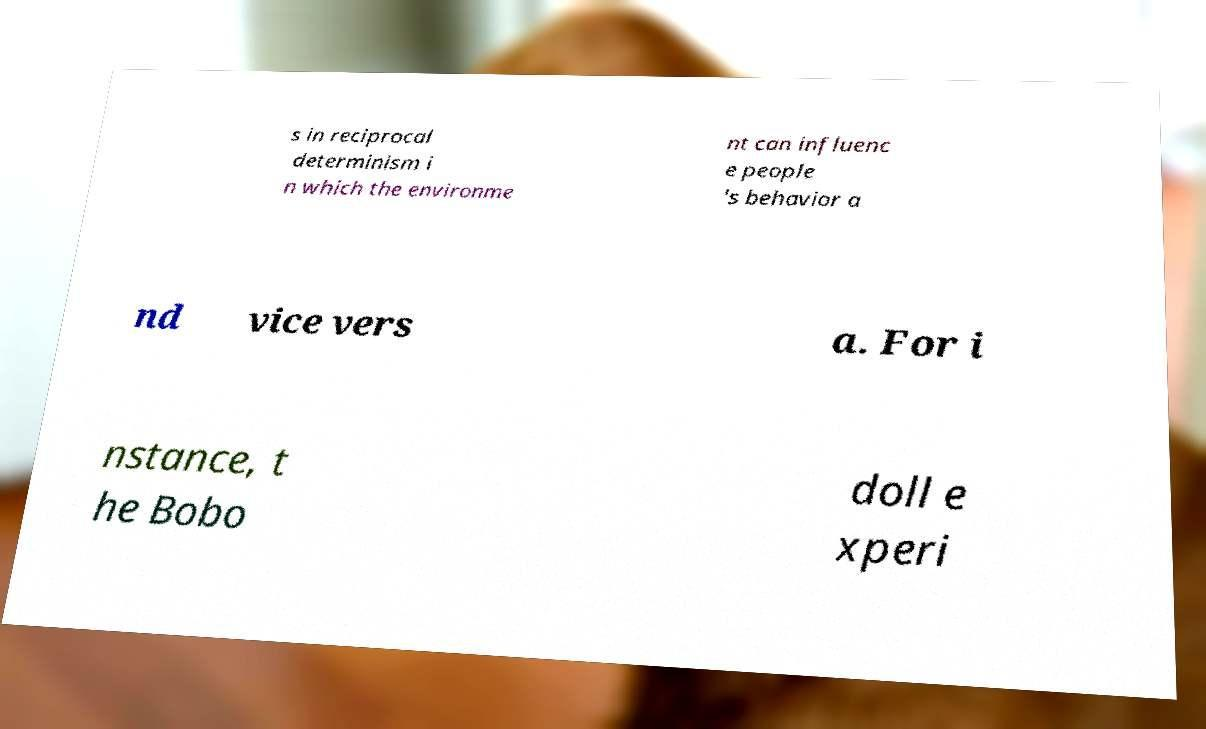For documentation purposes, I need the text within this image transcribed. Could you provide that? s in reciprocal determinism i n which the environme nt can influenc e people 's behavior a nd vice vers a. For i nstance, t he Bobo doll e xperi 